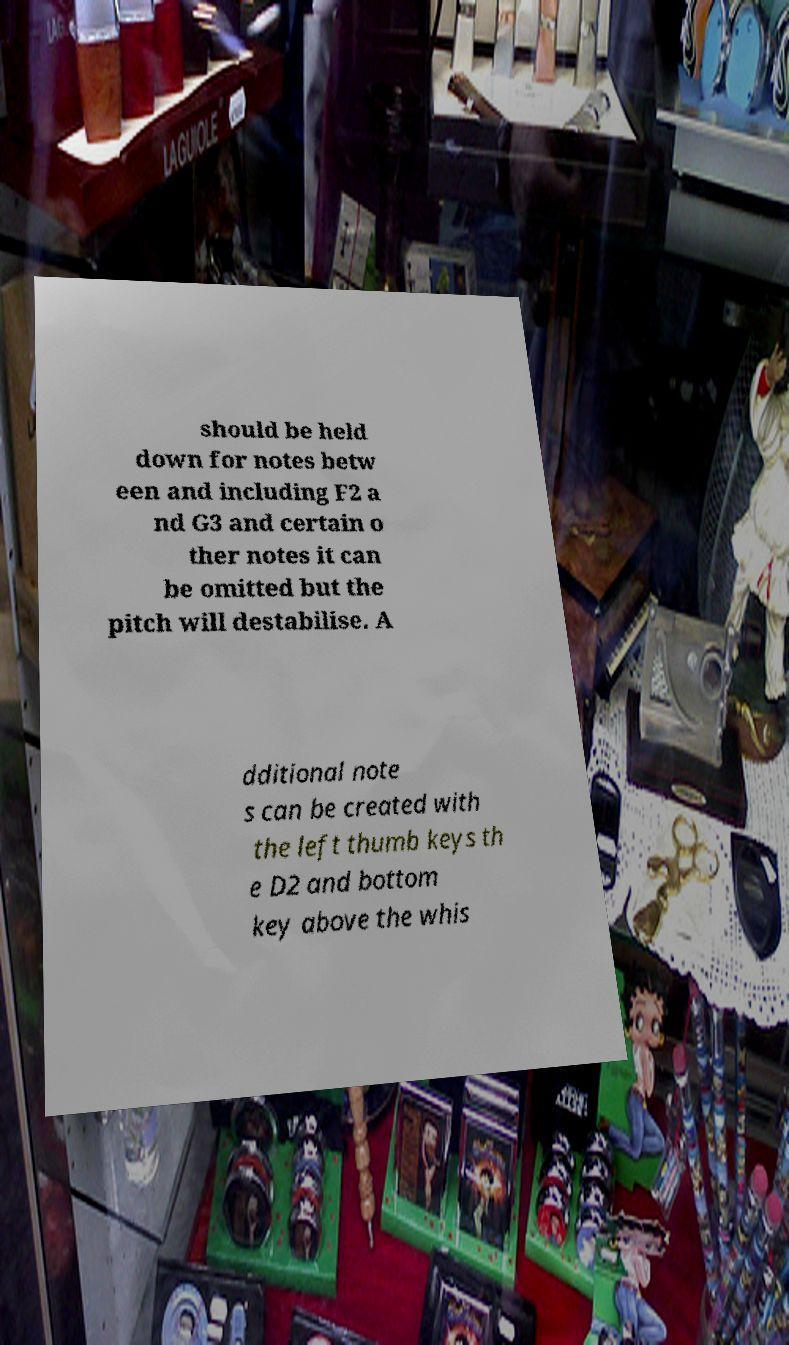Could you assist in decoding the text presented in this image and type it out clearly? should be held down for notes betw een and including F2 a nd G3 and certain o ther notes it can be omitted but the pitch will destabilise. A dditional note s can be created with the left thumb keys th e D2 and bottom key above the whis 